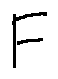Convert formula to latex. <formula><loc_0><loc_0><loc_500><loc_500>F</formula> 